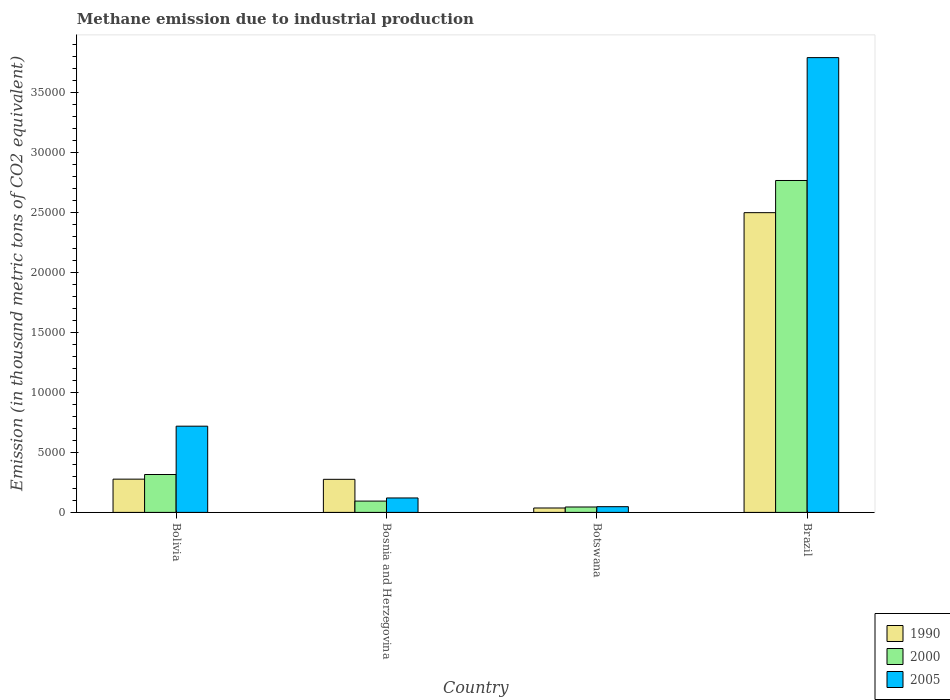Are the number of bars per tick equal to the number of legend labels?
Offer a very short reply. Yes. Are the number of bars on each tick of the X-axis equal?
Offer a very short reply. Yes. What is the label of the 2nd group of bars from the left?
Keep it short and to the point. Bosnia and Herzegovina. What is the amount of methane emitted in 1990 in Bosnia and Herzegovina?
Give a very brief answer. 2758.5. Across all countries, what is the maximum amount of methane emitted in 2000?
Ensure brevity in your answer.  2.77e+04. Across all countries, what is the minimum amount of methane emitted in 2000?
Give a very brief answer. 451.3. In which country was the amount of methane emitted in 2000 minimum?
Offer a terse response. Botswana. What is the total amount of methane emitted in 1990 in the graph?
Offer a terse response. 3.09e+04. What is the difference between the amount of methane emitted in 1990 in Botswana and that in Brazil?
Provide a succinct answer. -2.46e+04. What is the difference between the amount of methane emitted in 1990 in Bosnia and Herzegovina and the amount of methane emitted in 2000 in Botswana?
Provide a succinct answer. 2307.2. What is the average amount of methane emitted in 2000 per country?
Keep it short and to the point. 8059.7. What is the difference between the amount of methane emitted of/in 2000 and amount of methane emitted of/in 2005 in Bolivia?
Ensure brevity in your answer.  -4030.8. What is the ratio of the amount of methane emitted in 2000 in Bosnia and Herzegovina to that in Botswana?
Make the answer very short. 2.09. Is the amount of methane emitted in 2005 in Bolivia less than that in Bosnia and Herzegovina?
Make the answer very short. No. Is the difference between the amount of methane emitted in 2000 in Bolivia and Brazil greater than the difference between the amount of methane emitted in 2005 in Bolivia and Brazil?
Your response must be concise. Yes. What is the difference between the highest and the second highest amount of methane emitted in 2005?
Offer a terse response. -3.67e+04. What is the difference between the highest and the lowest amount of methane emitted in 2000?
Your answer should be very brief. 2.72e+04. Is the sum of the amount of methane emitted in 2000 in Bosnia and Herzegovina and Brazil greater than the maximum amount of methane emitted in 1990 across all countries?
Provide a short and direct response. Yes. What does the 2nd bar from the right in Bosnia and Herzegovina represents?
Provide a short and direct response. 2000. Is it the case that in every country, the sum of the amount of methane emitted in 2000 and amount of methane emitted in 2005 is greater than the amount of methane emitted in 1990?
Your response must be concise. No. How many bars are there?
Make the answer very short. 12. Are all the bars in the graph horizontal?
Ensure brevity in your answer.  No. What is the difference between two consecutive major ticks on the Y-axis?
Offer a very short reply. 5000. Does the graph contain grids?
Your answer should be very brief. No. Where does the legend appear in the graph?
Offer a very short reply. Bottom right. How many legend labels are there?
Give a very brief answer. 3. What is the title of the graph?
Your answer should be compact. Methane emission due to industrial production. What is the label or title of the Y-axis?
Offer a very short reply. Emission (in thousand metric tons of CO2 equivalent). What is the Emission (in thousand metric tons of CO2 equivalent) of 1990 in Bolivia?
Make the answer very short. 2773.8. What is the Emission (in thousand metric tons of CO2 equivalent) in 2000 in Bolivia?
Provide a short and direct response. 3160.9. What is the Emission (in thousand metric tons of CO2 equivalent) in 2005 in Bolivia?
Provide a succinct answer. 7191.7. What is the Emission (in thousand metric tons of CO2 equivalent) of 1990 in Bosnia and Herzegovina?
Offer a very short reply. 2758.5. What is the Emission (in thousand metric tons of CO2 equivalent) of 2000 in Bosnia and Herzegovina?
Ensure brevity in your answer.  943.2. What is the Emission (in thousand metric tons of CO2 equivalent) of 2005 in Bosnia and Herzegovina?
Your response must be concise. 1204.3. What is the Emission (in thousand metric tons of CO2 equivalent) of 1990 in Botswana?
Your answer should be compact. 367.9. What is the Emission (in thousand metric tons of CO2 equivalent) of 2000 in Botswana?
Your answer should be very brief. 451.3. What is the Emission (in thousand metric tons of CO2 equivalent) of 2005 in Botswana?
Your answer should be compact. 477.3. What is the Emission (in thousand metric tons of CO2 equivalent) in 1990 in Brazil?
Give a very brief answer. 2.50e+04. What is the Emission (in thousand metric tons of CO2 equivalent) in 2000 in Brazil?
Make the answer very short. 2.77e+04. What is the Emission (in thousand metric tons of CO2 equivalent) in 2005 in Brazil?
Ensure brevity in your answer.  3.79e+04. Across all countries, what is the maximum Emission (in thousand metric tons of CO2 equivalent) in 1990?
Provide a succinct answer. 2.50e+04. Across all countries, what is the maximum Emission (in thousand metric tons of CO2 equivalent) of 2000?
Your answer should be very brief. 2.77e+04. Across all countries, what is the maximum Emission (in thousand metric tons of CO2 equivalent) in 2005?
Offer a terse response. 3.79e+04. Across all countries, what is the minimum Emission (in thousand metric tons of CO2 equivalent) of 1990?
Keep it short and to the point. 367.9. Across all countries, what is the minimum Emission (in thousand metric tons of CO2 equivalent) of 2000?
Provide a succinct answer. 451.3. Across all countries, what is the minimum Emission (in thousand metric tons of CO2 equivalent) in 2005?
Provide a short and direct response. 477.3. What is the total Emission (in thousand metric tons of CO2 equivalent) of 1990 in the graph?
Ensure brevity in your answer.  3.09e+04. What is the total Emission (in thousand metric tons of CO2 equivalent) in 2000 in the graph?
Give a very brief answer. 3.22e+04. What is the total Emission (in thousand metric tons of CO2 equivalent) of 2005 in the graph?
Provide a succinct answer. 4.68e+04. What is the difference between the Emission (in thousand metric tons of CO2 equivalent) of 2000 in Bolivia and that in Bosnia and Herzegovina?
Provide a succinct answer. 2217.7. What is the difference between the Emission (in thousand metric tons of CO2 equivalent) in 2005 in Bolivia and that in Bosnia and Herzegovina?
Your response must be concise. 5987.4. What is the difference between the Emission (in thousand metric tons of CO2 equivalent) in 1990 in Bolivia and that in Botswana?
Your answer should be compact. 2405.9. What is the difference between the Emission (in thousand metric tons of CO2 equivalent) in 2000 in Bolivia and that in Botswana?
Provide a succinct answer. 2709.6. What is the difference between the Emission (in thousand metric tons of CO2 equivalent) in 2005 in Bolivia and that in Botswana?
Your answer should be very brief. 6714.4. What is the difference between the Emission (in thousand metric tons of CO2 equivalent) of 1990 in Bolivia and that in Brazil?
Provide a succinct answer. -2.22e+04. What is the difference between the Emission (in thousand metric tons of CO2 equivalent) of 2000 in Bolivia and that in Brazil?
Your answer should be compact. -2.45e+04. What is the difference between the Emission (in thousand metric tons of CO2 equivalent) of 2005 in Bolivia and that in Brazil?
Ensure brevity in your answer.  -3.07e+04. What is the difference between the Emission (in thousand metric tons of CO2 equivalent) in 1990 in Bosnia and Herzegovina and that in Botswana?
Make the answer very short. 2390.6. What is the difference between the Emission (in thousand metric tons of CO2 equivalent) of 2000 in Bosnia and Herzegovina and that in Botswana?
Your answer should be compact. 491.9. What is the difference between the Emission (in thousand metric tons of CO2 equivalent) in 2005 in Bosnia and Herzegovina and that in Botswana?
Make the answer very short. 727. What is the difference between the Emission (in thousand metric tons of CO2 equivalent) in 1990 in Bosnia and Herzegovina and that in Brazil?
Offer a very short reply. -2.22e+04. What is the difference between the Emission (in thousand metric tons of CO2 equivalent) of 2000 in Bosnia and Herzegovina and that in Brazil?
Keep it short and to the point. -2.67e+04. What is the difference between the Emission (in thousand metric tons of CO2 equivalent) of 2005 in Bosnia and Herzegovina and that in Brazil?
Offer a terse response. -3.67e+04. What is the difference between the Emission (in thousand metric tons of CO2 equivalent) in 1990 in Botswana and that in Brazil?
Provide a short and direct response. -2.46e+04. What is the difference between the Emission (in thousand metric tons of CO2 equivalent) of 2000 in Botswana and that in Brazil?
Provide a short and direct response. -2.72e+04. What is the difference between the Emission (in thousand metric tons of CO2 equivalent) in 2005 in Botswana and that in Brazil?
Provide a short and direct response. -3.75e+04. What is the difference between the Emission (in thousand metric tons of CO2 equivalent) of 1990 in Bolivia and the Emission (in thousand metric tons of CO2 equivalent) of 2000 in Bosnia and Herzegovina?
Your answer should be compact. 1830.6. What is the difference between the Emission (in thousand metric tons of CO2 equivalent) of 1990 in Bolivia and the Emission (in thousand metric tons of CO2 equivalent) of 2005 in Bosnia and Herzegovina?
Offer a very short reply. 1569.5. What is the difference between the Emission (in thousand metric tons of CO2 equivalent) of 2000 in Bolivia and the Emission (in thousand metric tons of CO2 equivalent) of 2005 in Bosnia and Herzegovina?
Your answer should be very brief. 1956.6. What is the difference between the Emission (in thousand metric tons of CO2 equivalent) in 1990 in Bolivia and the Emission (in thousand metric tons of CO2 equivalent) in 2000 in Botswana?
Your response must be concise. 2322.5. What is the difference between the Emission (in thousand metric tons of CO2 equivalent) of 1990 in Bolivia and the Emission (in thousand metric tons of CO2 equivalent) of 2005 in Botswana?
Provide a succinct answer. 2296.5. What is the difference between the Emission (in thousand metric tons of CO2 equivalent) of 2000 in Bolivia and the Emission (in thousand metric tons of CO2 equivalent) of 2005 in Botswana?
Provide a short and direct response. 2683.6. What is the difference between the Emission (in thousand metric tons of CO2 equivalent) in 1990 in Bolivia and the Emission (in thousand metric tons of CO2 equivalent) in 2000 in Brazil?
Your answer should be very brief. -2.49e+04. What is the difference between the Emission (in thousand metric tons of CO2 equivalent) in 1990 in Bolivia and the Emission (in thousand metric tons of CO2 equivalent) in 2005 in Brazil?
Provide a succinct answer. -3.52e+04. What is the difference between the Emission (in thousand metric tons of CO2 equivalent) of 2000 in Bolivia and the Emission (in thousand metric tons of CO2 equivalent) of 2005 in Brazil?
Keep it short and to the point. -3.48e+04. What is the difference between the Emission (in thousand metric tons of CO2 equivalent) of 1990 in Bosnia and Herzegovina and the Emission (in thousand metric tons of CO2 equivalent) of 2000 in Botswana?
Your answer should be very brief. 2307.2. What is the difference between the Emission (in thousand metric tons of CO2 equivalent) in 1990 in Bosnia and Herzegovina and the Emission (in thousand metric tons of CO2 equivalent) in 2005 in Botswana?
Offer a very short reply. 2281.2. What is the difference between the Emission (in thousand metric tons of CO2 equivalent) of 2000 in Bosnia and Herzegovina and the Emission (in thousand metric tons of CO2 equivalent) of 2005 in Botswana?
Your answer should be compact. 465.9. What is the difference between the Emission (in thousand metric tons of CO2 equivalent) of 1990 in Bosnia and Herzegovina and the Emission (in thousand metric tons of CO2 equivalent) of 2000 in Brazil?
Provide a short and direct response. -2.49e+04. What is the difference between the Emission (in thousand metric tons of CO2 equivalent) of 1990 in Bosnia and Herzegovina and the Emission (in thousand metric tons of CO2 equivalent) of 2005 in Brazil?
Provide a succinct answer. -3.52e+04. What is the difference between the Emission (in thousand metric tons of CO2 equivalent) of 2000 in Bosnia and Herzegovina and the Emission (in thousand metric tons of CO2 equivalent) of 2005 in Brazil?
Ensure brevity in your answer.  -3.70e+04. What is the difference between the Emission (in thousand metric tons of CO2 equivalent) of 1990 in Botswana and the Emission (in thousand metric tons of CO2 equivalent) of 2000 in Brazil?
Your response must be concise. -2.73e+04. What is the difference between the Emission (in thousand metric tons of CO2 equivalent) in 1990 in Botswana and the Emission (in thousand metric tons of CO2 equivalent) in 2005 in Brazil?
Your answer should be compact. -3.76e+04. What is the difference between the Emission (in thousand metric tons of CO2 equivalent) of 2000 in Botswana and the Emission (in thousand metric tons of CO2 equivalent) of 2005 in Brazil?
Keep it short and to the point. -3.75e+04. What is the average Emission (in thousand metric tons of CO2 equivalent) of 1990 per country?
Make the answer very short. 7725.1. What is the average Emission (in thousand metric tons of CO2 equivalent) in 2000 per country?
Offer a very short reply. 8059.7. What is the average Emission (in thousand metric tons of CO2 equivalent) of 2005 per country?
Offer a very short reply. 1.17e+04. What is the difference between the Emission (in thousand metric tons of CO2 equivalent) of 1990 and Emission (in thousand metric tons of CO2 equivalent) of 2000 in Bolivia?
Offer a very short reply. -387.1. What is the difference between the Emission (in thousand metric tons of CO2 equivalent) of 1990 and Emission (in thousand metric tons of CO2 equivalent) of 2005 in Bolivia?
Ensure brevity in your answer.  -4417.9. What is the difference between the Emission (in thousand metric tons of CO2 equivalent) of 2000 and Emission (in thousand metric tons of CO2 equivalent) of 2005 in Bolivia?
Your answer should be compact. -4030.8. What is the difference between the Emission (in thousand metric tons of CO2 equivalent) of 1990 and Emission (in thousand metric tons of CO2 equivalent) of 2000 in Bosnia and Herzegovina?
Offer a terse response. 1815.3. What is the difference between the Emission (in thousand metric tons of CO2 equivalent) of 1990 and Emission (in thousand metric tons of CO2 equivalent) of 2005 in Bosnia and Herzegovina?
Ensure brevity in your answer.  1554.2. What is the difference between the Emission (in thousand metric tons of CO2 equivalent) in 2000 and Emission (in thousand metric tons of CO2 equivalent) in 2005 in Bosnia and Herzegovina?
Provide a succinct answer. -261.1. What is the difference between the Emission (in thousand metric tons of CO2 equivalent) of 1990 and Emission (in thousand metric tons of CO2 equivalent) of 2000 in Botswana?
Your response must be concise. -83.4. What is the difference between the Emission (in thousand metric tons of CO2 equivalent) of 1990 and Emission (in thousand metric tons of CO2 equivalent) of 2005 in Botswana?
Your answer should be very brief. -109.4. What is the difference between the Emission (in thousand metric tons of CO2 equivalent) in 2000 and Emission (in thousand metric tons of CO2 equivalent) in 2005 in Botswana?
Provide a short and direct response. -26. What is the difference between the Emission (in thousand metric tons of CO2 equivalent) of 1990 and Emission (in thousand metric tons of CO2 equivalent) of 2000 in Brazil?
Keep it short and to the point. -2683.2. What is the difference between the Emission (in thousand metric tons of CO2 equivalent) of 1990 and Emission (in thousand metric tons of CO2 equivalent) of 2005 in Brazil?
Offer a terse response. -1.29e+04. What is the difference between the Emission (in thousand metric tons of CO2 equivalent) of 2000 and Emission (in thousand metric tons of CO2 equivalent) of 2005 in Brazil?
Offer a terse response. -1.02e+04. What is the ratio of the Emission (in thousand metric tons of CO2 equivalent) of 1990 in Bolivia to that in Bosnia and Herzegovina?
Offer a terse response. 1.01. What is the ratio of the Emission (in thousand metric tons of CO2 equivalent) in 2000 in Bolivia to that in Bosnia and Herzegovina?
Keep it short and to the point. 3.35. What is the ratio of the Emission (in thousand metric tons of CO2 equivalent) of 2005 in Bolivia to that in Bosnia and Herzegovina?
Make the answer very short. 5.97. What is the ratio of the Emission (in thousand metric tons of CO2 equivalent) of 1990 in Bolivia to that in Botswana?
Offer a terse response. 7.54. What is the ratio of the Emission (in thousand metric tons of CO2 equivalent) of 2000 in Bolivia to that in Botswana?
Your answer should be very brief. 7. What is the ratio of the Emission (in thousand metric tons of CO2 equivalent) in 2005 in Bolivia to that in Botswana?
Make the answer very short. 15.07. What is the ratio of the Emission (in thousand metric tons of CO2 equivalent) in 1990 in Bolivia to that in Brazil?
Keep it short and to the point. 0.11. What is the ratio of the Emission (in thousand metric tons of CO2 equivalent) in 2000 in Bolivia to that in Brazil?
Your answer should be very brief. 0.11. What is the ratio of the Emission (in thousand metric tons of CO2 equivalent) in 2005 in Bolivia to that in Brazil?
Your answer should be compact. 0.19. What is the ratio of the Emission (in thousand metric tons of CO2 equivalent) of 1990 in Bosnia and Herzegovina to that in Botswana?
Offer a terse response. 7.5. What is the ratio of the Emission (in thousand metric tons of CO2 equivalent) of 2000 in Bosnia and Herzegovina to that in Botswana?
Provide a short and direct response. 2.09. What is the ratio of the Emission (in thousand metric tons of CO2 equivalent) of 2005 in Bosnia and Herzegovina to that in Botswana?
Keep it short and to the point. 2.52. What is the ratio of the Emission (in thousand metric tons of CO2 equivalent) in 1990 in Bosnia and Herzegovina to that in Brazil?
Your answer should be compact. 0.11. What is the ratio of the Emission (in thousand metric tons of CO2 equivalent) of 2000 in Bosnia and Herzegovina to that in Brazil?
Your response must be concise. 0.03. What is the ratio of the Emission (in thousand metric tons of CO2 equivalent) of 2005 in Bosnia and Herzegovina to that in Brazil?
Offer a very short reply. 0.03. What is the ratio of the Emission (in thousand metric tons of CO2 equivalent) in 1990 in Botswana to that in Brazil?
Your response must be concise. 0.01. What is the ratio of the Emission (in thousand metric tons of CO2 equivalent) in 2000 in Botswana to that in Brazil?
Provide a short and direct response. 0.02. What is the ratio of the Emission (in thousand metric tons of CO2 equivalent) of 2005 in Botswana to that in Brazil?
Ensure brevity in your answer.  0.01. What is the difference between the highest and the second highest Emission (in thousand metric tons of CO2 equivalent) in 1990?
Make the answer very short. 2.22e+04. What is the difference between the highest and the second highest Emission (in thousand metric tons of CO2 equivalent) in 2000?
Offer a terse response. 2.45e+04. What is the difference between the highest and the second highest Emission (in thousand metric tons of CO2 equivalent) in 2005?
Your answer should be compact. 3.07e+04. What is the difference between the highest and the lowest Emission (in thousand metric tons of CO2 equivalent) of 1990?
Provide a succinct answer. 2.46e+04. What is the difference between the highest and the lowest Emission (in thousand metric tons of CO2 equivalent) of 2000?
Keep it short and to the point. 2.72e+04. What is the difference between the highest and the lowest Emission (in thousand metric tons of CO2 equivalent) in 2005?
Your answer should be very brief. 3.75e+04. 